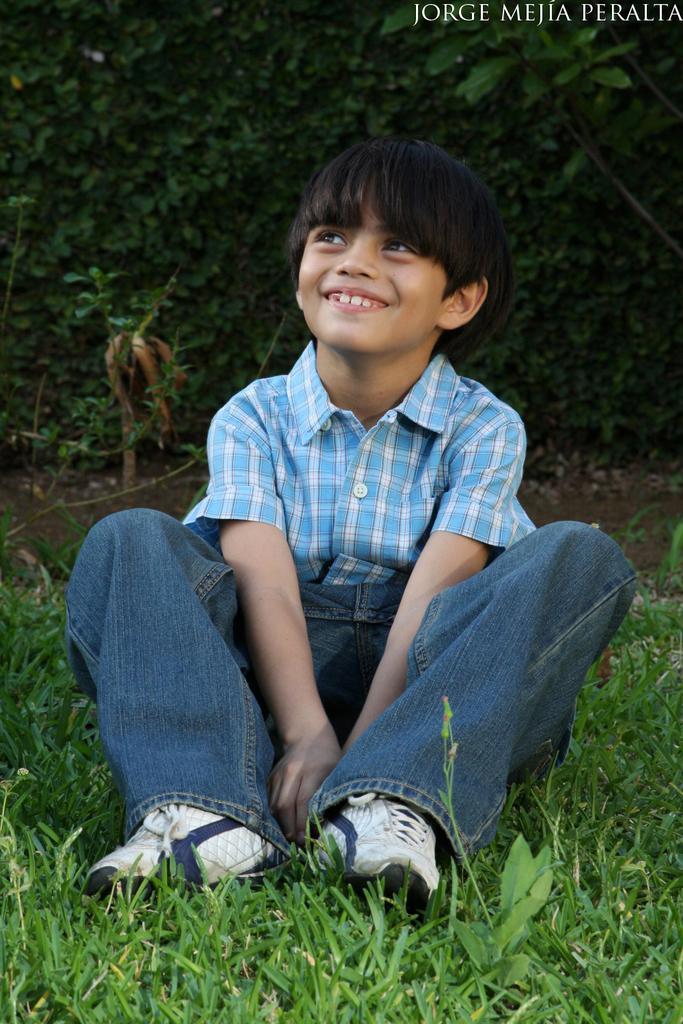Please provide a concise description of this image. In this image there is a boy sitting on the grass and he is smiling. In the background of the image there are trees. There is some text on the top right of the image. 